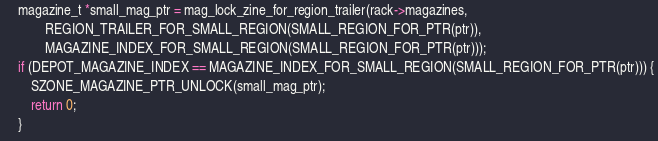Convert code to text. <code><loc_0><loc_0><loc_500><loc_500><_C_>
	magazine_t *small_mag_ptr = mag_lock_zine_for_region_trailer(rack->magazines,
			REGION_TRAILER_FOR_SMALL_REGION(SMALL_REGION_FOR_PTR(ptr)),
			MAGAZINE_INDEX_FOR_SMALL_REGION(SMALL_REGION_FOR_PTR(ptr)));
	if (DEPOT_MAGAZINE_INDEX == MAGAZINE_INDEX_FOR_SMALL_REGION(SMALL_REGION_FOR_PTR(ptr))) {
		SZONE_MAGAZINE_PTR_UNLOCK(small_mag_ptr);
		return 0;
	}
</code> 